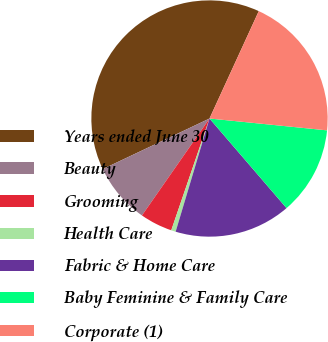<chart> <loc_0><loc_0><loc_500><loc_500><pie_chart><fcel>Years ended June 30<fcel>Beauty<fcel>Grooming<fcel>Health Care<fcel>Fabric & Home Care<fcel>Baby Feminine & Family Care<fcel>Corporate (1)<nl><fcel>38.89%<fcel>8.27%<fcel>4.44%<fcel>0.62%<fcel>15.93%<fcel>12.1%<fcel>19.75%<nl></chart> 